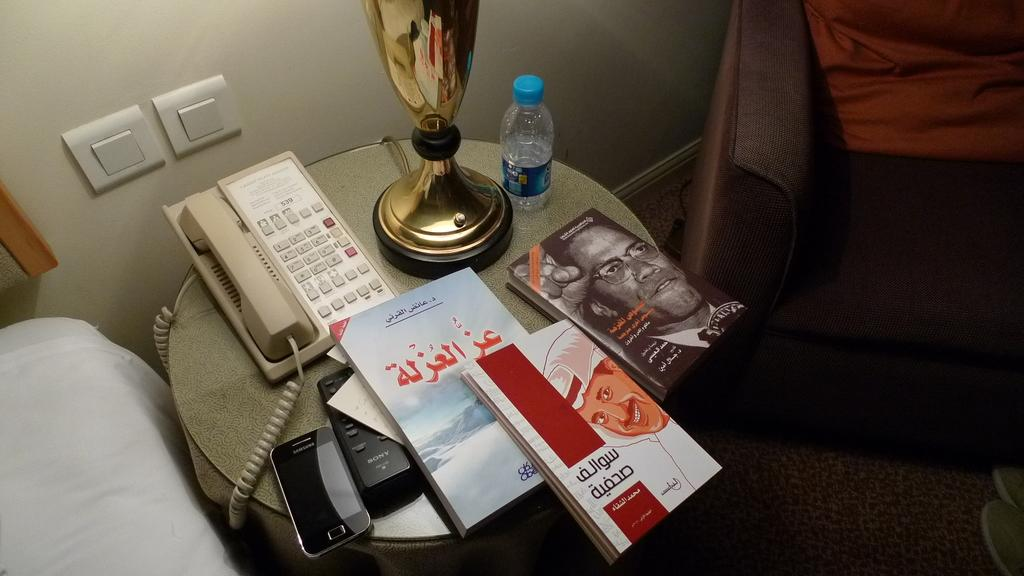<image>
Present a compact description of the photo's key features. Room number 539 is displayed on the phone on a bedside table that also includes various books and a Samsung phone. 